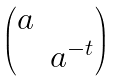<formula> <loc_0><loc_0><loc_500><loc_500>\begin{pmatrix} a & \\ & a ^ { - t } \end{pmatrix}</formula> 